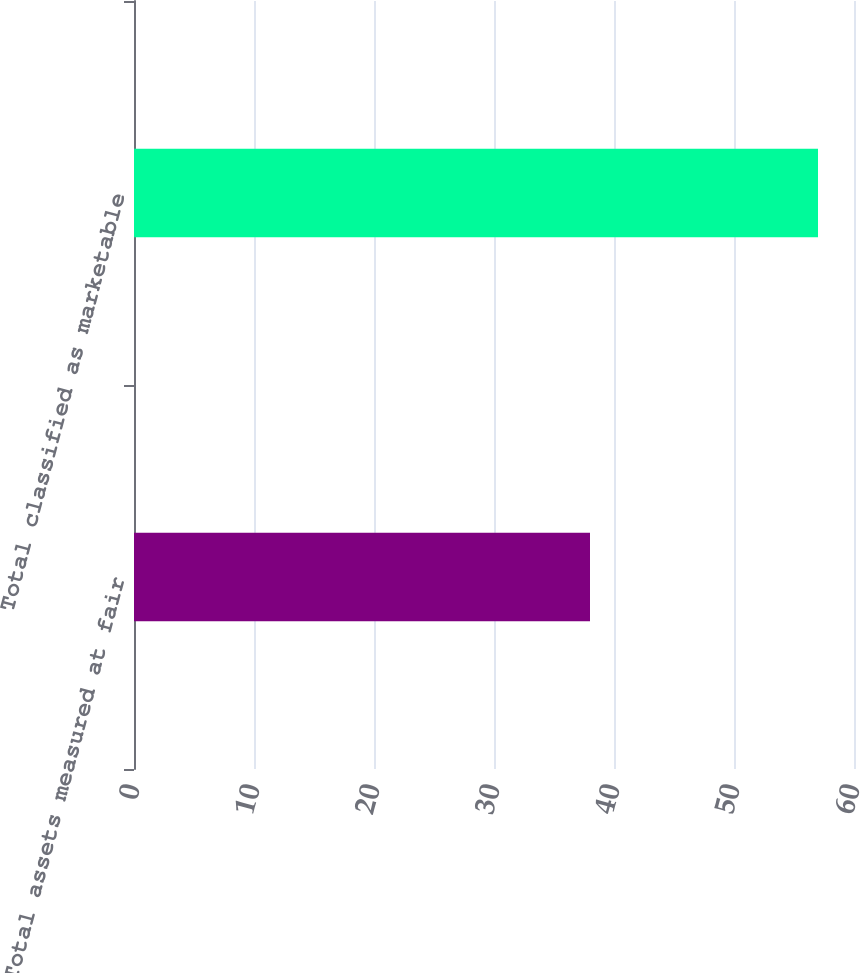Convert chart. <chart><loc_0><loc_0><loc_500><loc_500><bar_chart><fcel>Total assets measured at fair<fcel>Total classified as marketable<nl><fcel>38<fcel>57<nl></chart> 